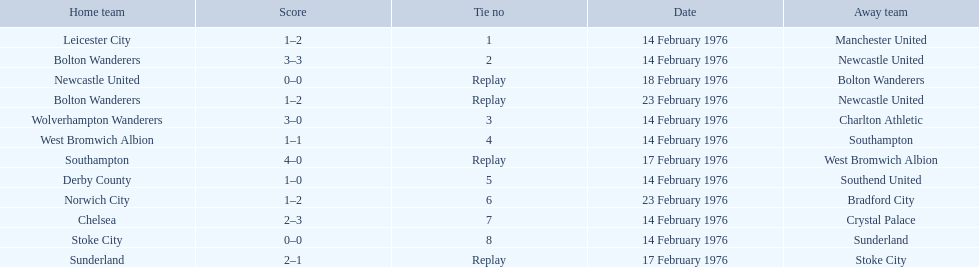What are all of the scores of the 1975-76 fa cup? 1–2, 3–3, 0–0, 1–2, 3–0, 1–1, 4–0, 1–0, 1–2, 2–3, 0–0, 2–1. What are the scores for manchester united or wolverhampton wanderers? 1–2, 3–0. Which has the highest score? 3–0. Who was this score for? Wolverhampton Wanderers. 